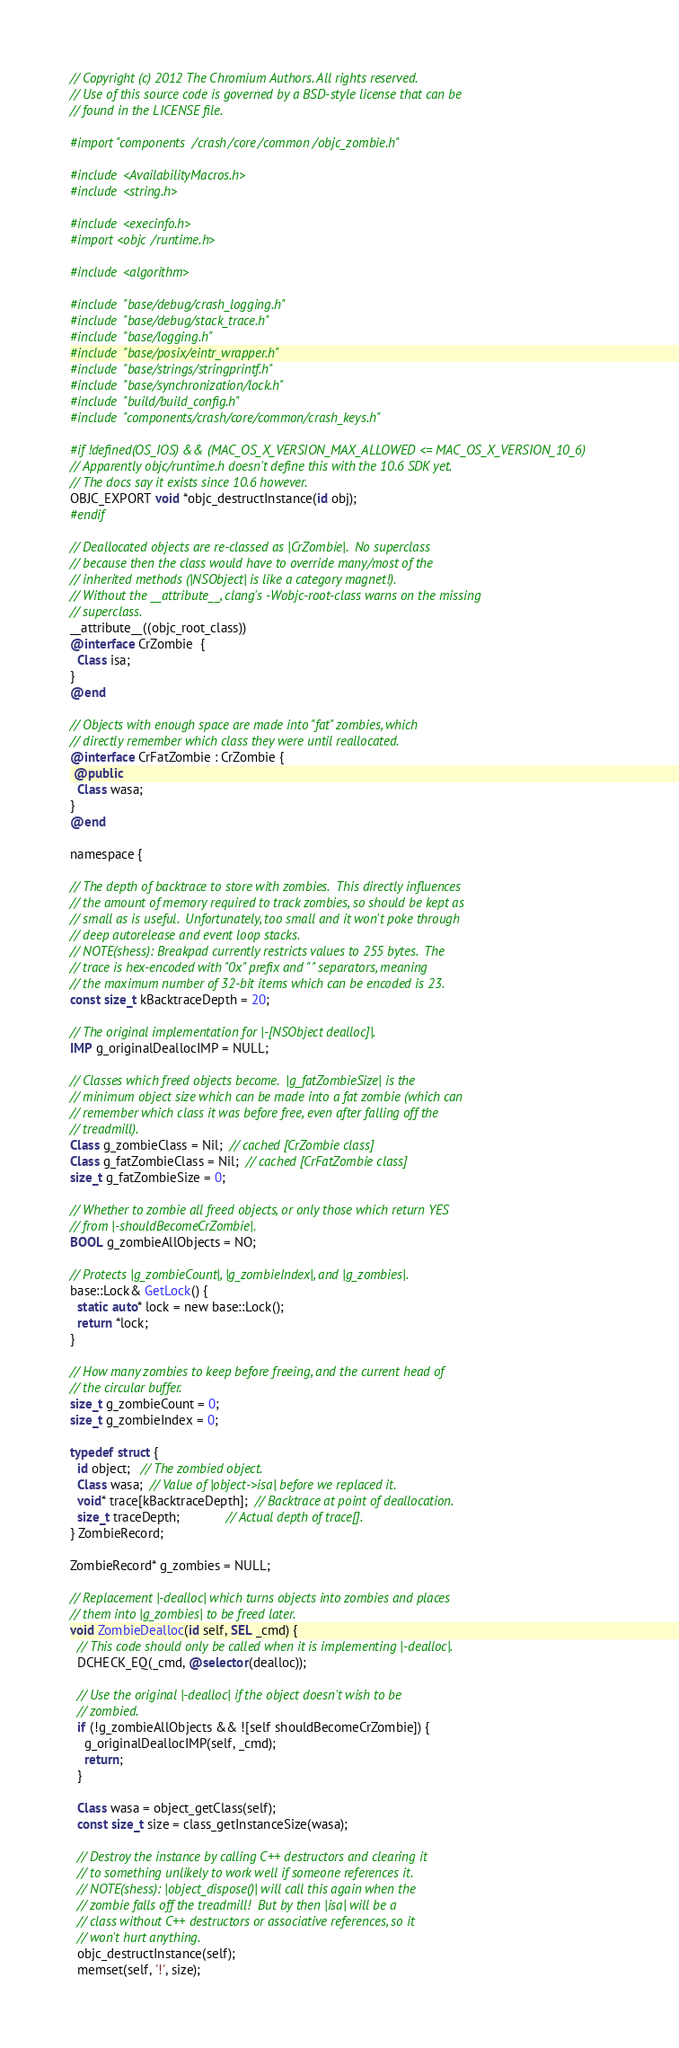Convert code to text. <code><loc_0><loc_0><loc_500><loc_500><_ObjectiveC_>// Copyright (c) 2012 The Chromium Authors. All rights reserved.
// Use of this source code is governed by a BSD-style license that can be
// found in the LICENSE file.

#import "components/crash/core/common/objc_zombie.h"

#include <AvailabilityMacros.h>
#include <string.h>

#include <execinfo.h>
#import <objc/runtime.h>

#include <algorithm>

#include "base/debug/crash_logging.h"
#include "base/debug/stack_trace.h"
#include "base/logging.h"
#include "base/posix/eintr_wrapper.h"
#include "base/strings/stringprintf.h"
#include "base/synchronization/lock.h"
#include "build/build_config.h"
#include "components/crash/core/common/crash_keys.h"

#if !defined(OS_IOS) && (MAC_OS_X_VERSION_MAX_ALLOWED <= MAC_OS_X_VERSION_10_6)
// Apparently objc/runtime.h doesn't define this with the 10.6 SDK yet.
// The docs say it exists since 10.6 however.
OBJC_EXPORT void *objc_destructInstance(id obj);
#endif

// Deallocated objects are re-classed as |CrZombie|.  No superclass
// because then the class would have to override many/most of the
// inherited methods (|NSObject| is like a category magnet!).
// Without the __attribute__, clang's -Wobjc-root-class warns on the missing
// superclass.
__attribute__((objc_root_class))
@interface CrZombie  {
  Class isa;
}
@end

// Objects with enough space are made into "fat" zombies, which
// directly remember which class they were until reallocated.
@interface CrFatZombie : CrZombie {
 @public
  Class wasa;
}
@end

namespace {

// The depth of backtrace to store with zombies.  This directly influences
// the amount of memory required to track zombies, so should be kept as
// small as is useful.  Unfortunately, too small and it won't poke through
// deep autorelease and event loop stacks.
// NOTE(shess): Breakpad currently restricts values to 255 bytes.  The
// trace is hex-encoded with "0x" prefix and " " separators, meaning
// the maximum number of 32-bit items which can be encoded is 23.
const size_t kBacktraceDepth = 20;

// The original implementation for |-[NSObject dealloc]|.
IMP g_originalDeallocIMP = NULL;

// Classes which freed objects become.  |g_fatZombieSize| is the
// minimum object size which can be made into a fat zombie (which can
// remember which class it was before free, even after falling off the
// treadmill).
Class g_zombieClass = Nil;  // cached [CrZombie class]
Class g_fatZombieClass = Nil;  // cached [CrFatZombie class]
size_t g_fatZombieSize = 0;

// Whether to zombie all freed objects, or only those which return YES
// from |-shouldBecomeCrZombie|.
BOOL g_zombieAllObjects = NO;

// Protects |g_zombieCount|, |g_zombieIndex|, and |g_zombies|.
base::Lock& GetLock() {
  static auto* lock = new base::Lock();
  return *lock;
}

// How many zombies to keep before freeing, and the current head of
// the circular buffer.
size_t g_zombieCount = 0;
size_t g_zombieIndex = 0;

typedef struct {
  id object;   // The zombied object.
  Class wasa;  // Value of |object->isa| before we replaced it.
  void* trace[kBacktraceDepth];  // Backtrace at point of deallocation.
  size_t traceDepth;             // Actual depth of trace[].
} ZombieRecord;

ZombieRecord* g_zombies = NULL;

// Replacement |-dealloc| which turns objects into zombies and places
// them into |g_zombies| to be freed later.
void ZombieDealloc(id self, SEL _cmd) {
  // This code should only be called when it is implementing |-dealloc|.
  DCHECK_EQ(_cmd, @selector(dealloc));

  // Use the original |-dealloc| if the object doesn't wish to be
  // zombied.
  if (!g_zombieAllObjects && ![self shouldBecomeCrZombie]) {
    g_originalDeallocIMP(self, _cmd);
    return;
  }

  Class wasa = object_getClass(self);
  const size_t size = class_getInstanceSize(wasa);

  // Destroy the instance by calling C++ destructors and clearing it
  // to something unlikely to work well if someone references it.
  // NOTE(shess): |object_dispose()| will call this again when the
  // zombie falls off the treadmill!  But by then |isa| will be a
  // class without C++ destructors or associative references, so it
  // won't hurt anything.
  objc_destructInstance(self);
  memset(self, '!', size);
</code> 